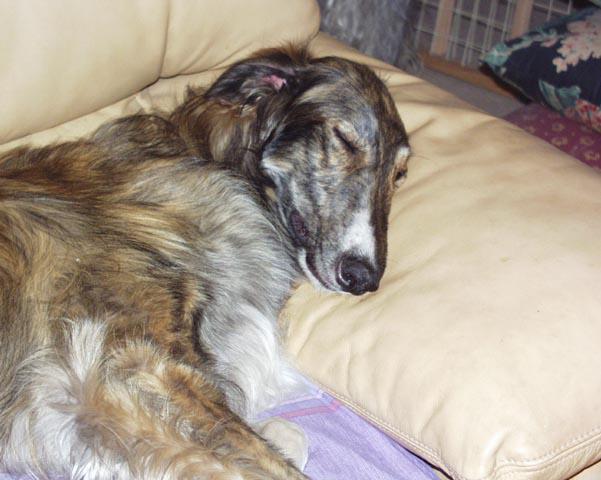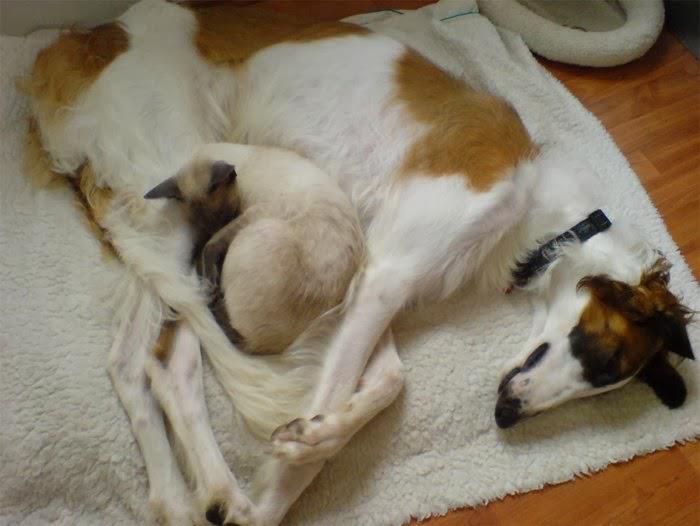The first image is the image on the left, the second image is the image on the right. For the images displayed, is the sentence "The dog in the image on the right is lying on a couch." factually correct? Answer yes or no. No. 